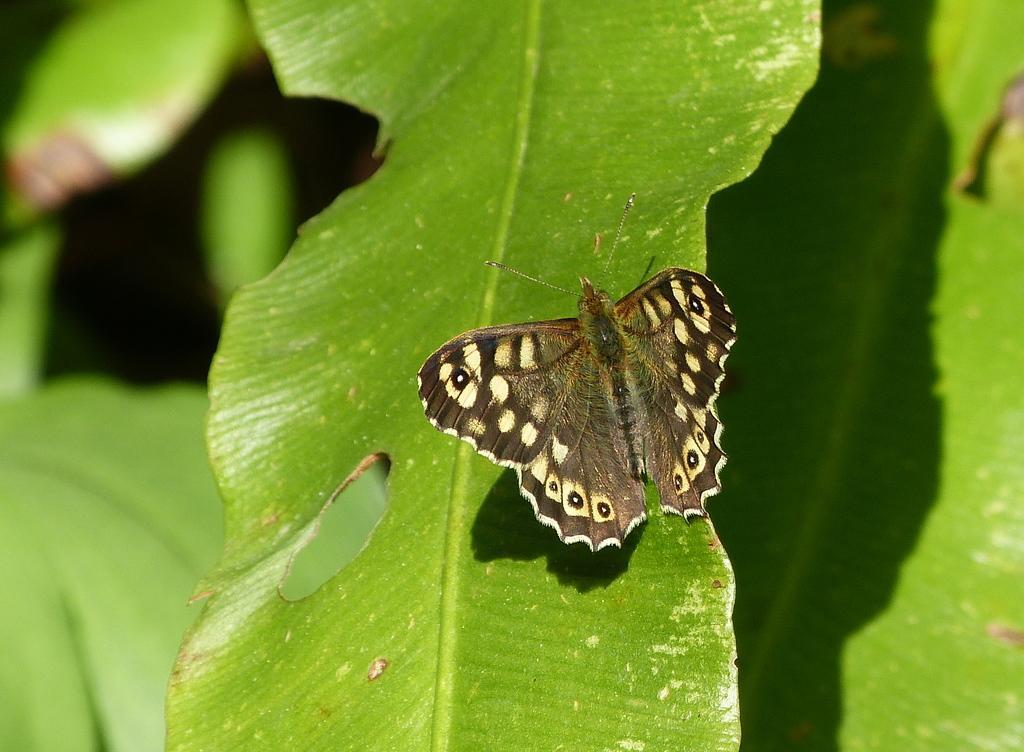How would you summarize this image in a sentence or two? In this image there is a butterfly on the leaf. Around the butterfly there are leaves. 